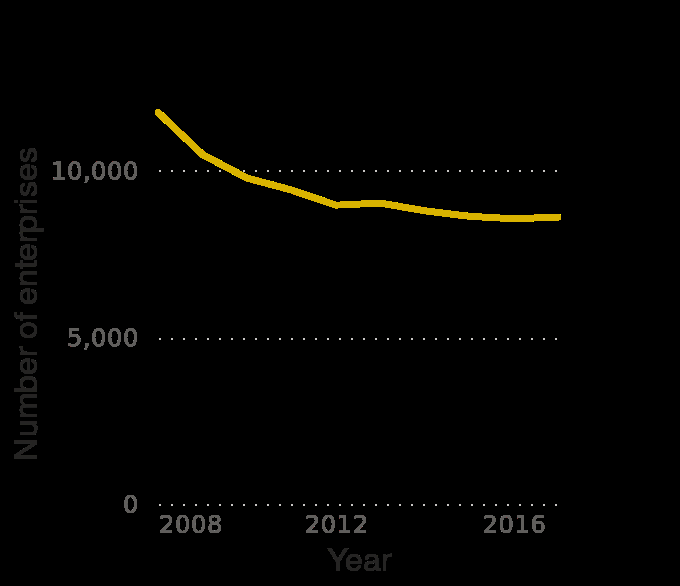<image>
Did the number of clothing manufacturing enterprises in Spain increase at all during this time?  Yes, the number of clothing manufacturing enterprises in Spain gradually increased for a year before decreasing again. How would you describe the overall trend in the number of clothing manufacturing enterprises in Spain during the given period?  The overall trend in the number of clothing manufacturing enterprises in Spain was a gradual decrease, followed by a brief increase, and then another decrease. please describe the details of the chart This is a line chart called Number of enterprises in the manufacture of clothing industry in Spain from 2008 to 2017. The x-axis shows Year on linear scale of range 2008 to 2016 while the y-axis measures Number of enterprises along linear scale of range 0 to 10,000. Offer a thorough analysis of the image. This line chart shows the decline in the manufacture of clothing industry in Spain between 2008 and 2017. The line shows a continous decline. 